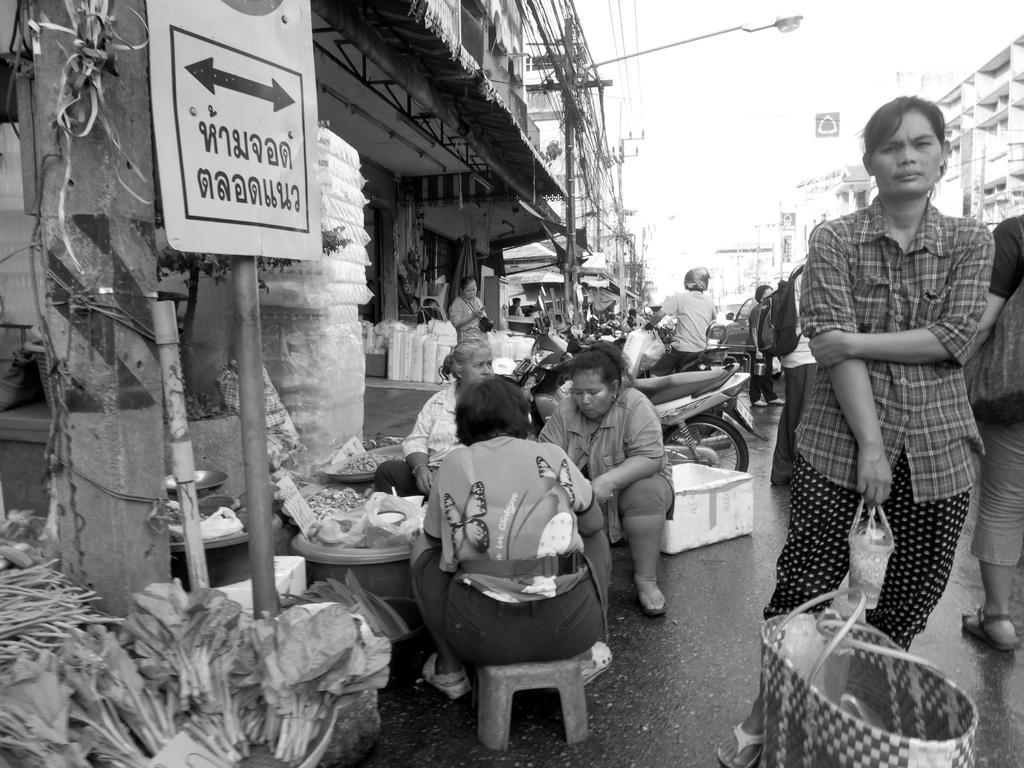Describe this image in one or two sentences. This is black and white image were we can see people are sitting and standing on the road. Left side of the image shops and buildings are there. We can see street light and wires. Bottom of the image one basket and vegetables are there. 